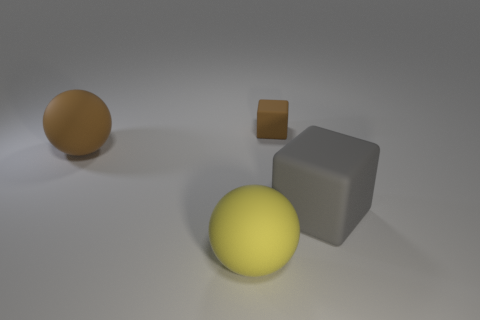How many other things are the same size as the yellow thing?
Provide a succinct answer. 2. What size is the thing that is the same color as the small block?
Your response must be concise. Large. How many other cubes have the same color as the tiny block?
Ensure brevity in your answer.  0. The gray matte thing is what shape?
Give a very brief answer. Cube. What is the color of the matte object that is behind the gray thing and on the left side of the small brown object?
Provide a short and direct response. Brown. What material is the big yellow sphere?
Your answer should be very brief. Rubber. The large rubber object to the right of the small cube has what shape?
Provide a short and direct response. Cube. There is a rubber ball that is the same size as the yellow thing; what color is it?
Your answer should be very brief. Brown. Is the material of the big thing to the right of the tiny brown cube the same as the big brown object?
Keep it short and to the point. Yes. There is a matte thing that is in front of the brown rubber ball and on the left side of the big block; what is its size?
Offer a terse response. Large. 